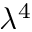Convert formula to latex. <formula><loc_0><loc_0><loc_500><loc_500>\lambda ^ { 4 }</formula> 